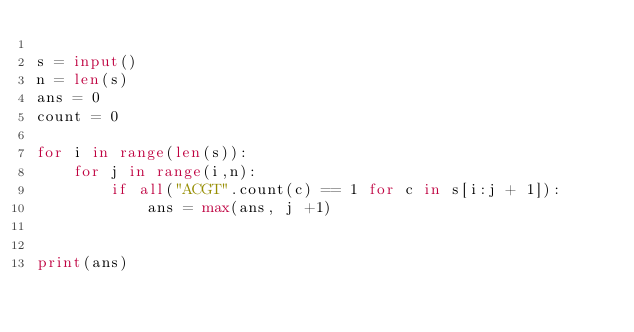Convert code to text. <code><loc_0><loc_0><loc_500><loc_500><_Python_>
s = input()
n = len(s)
ans = 0
count = 0

for i in range(len(s)):
    for j in range(i,n):
        if all("ACGT".count(c) == 1 for c in s[i:j + 1]):
            ans = max(ans, j +1)


print(ans)
</code> 